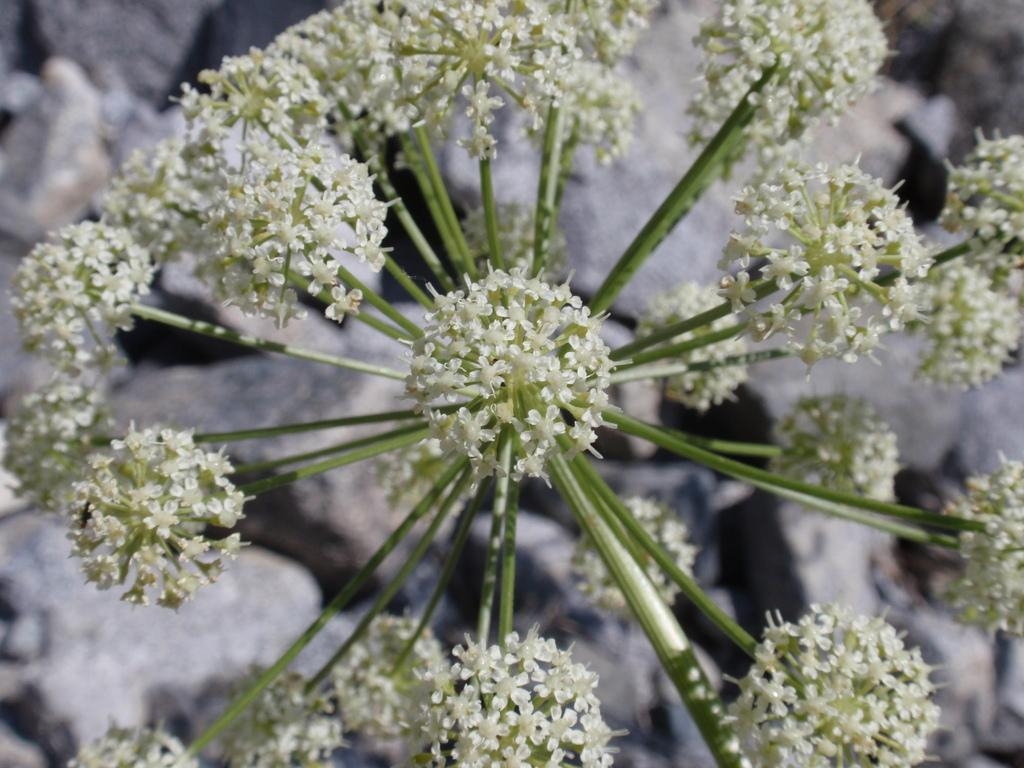What type of plants can be seen in the image? There are flowers in the image. Where are the flowers located in the image? The flowers are in the front of the image. What else can be seen at the bottom of the image? There are stones at the bottom of the image. Can you see a plane flying over the flowers in the image? There is no plane visible in the image; it only features flowers and stones. 